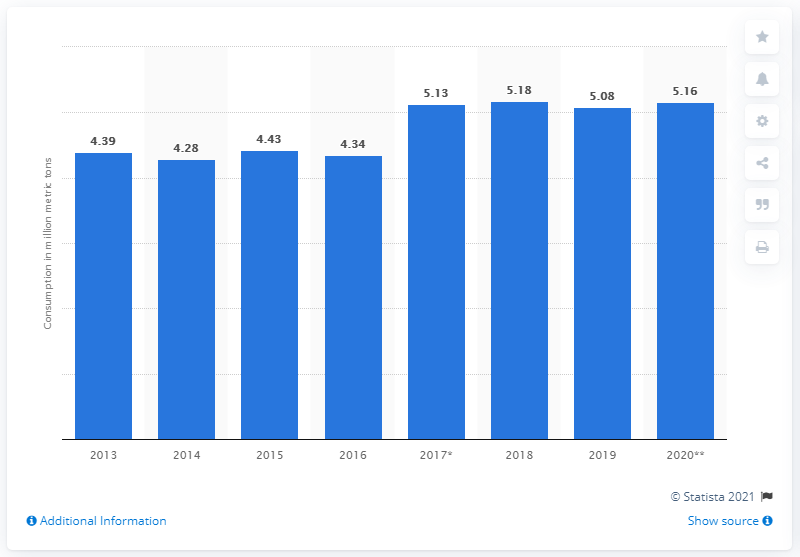Draw attention to some important aspects in this diagram. In 2019, Argentina's meat consumption was 5.08 million metric tons. By 2020, the estimated volume of Argentina's meat consumption was 5.16 million metric tons. 